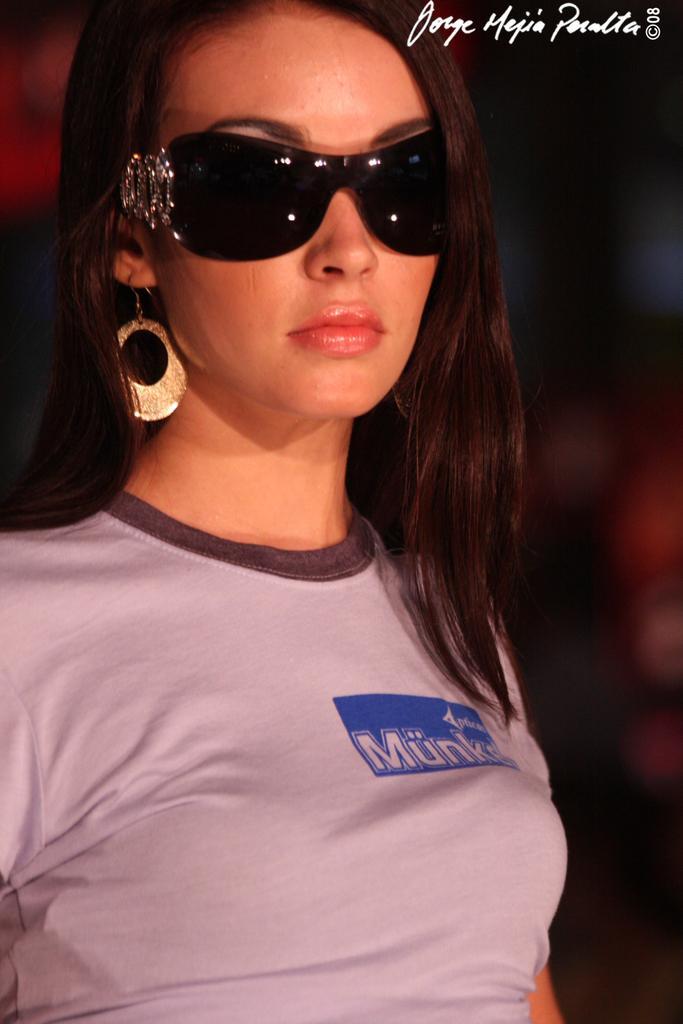Could you give a brief overview of what you see in this image? In this image we can see a woman wearing the glasses and the background is blurred. We can also see the text. 